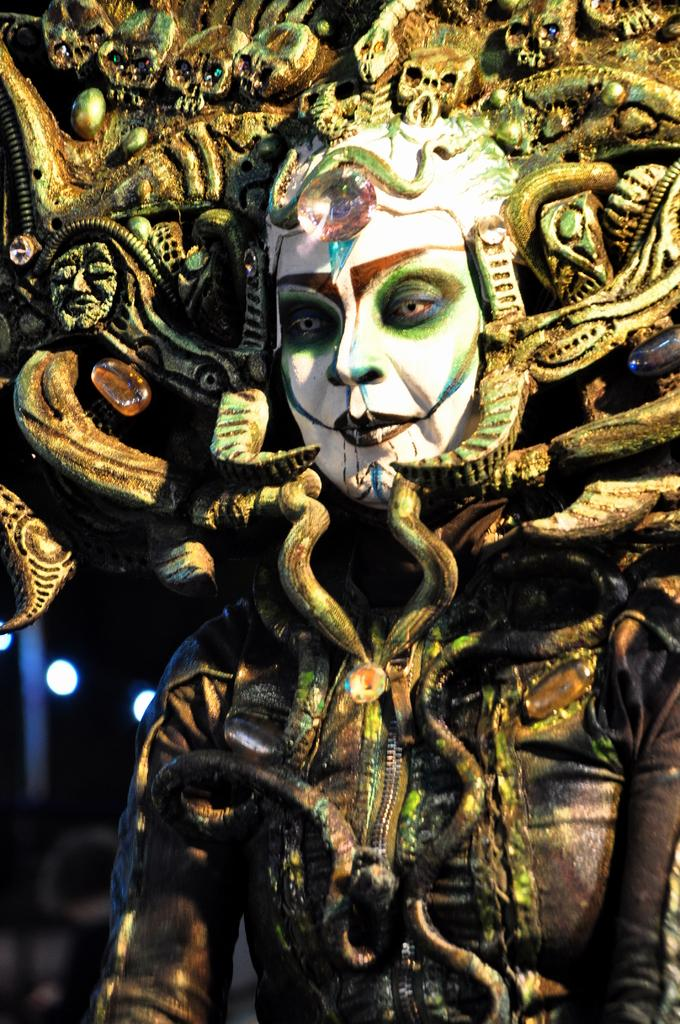What can be seen in the image? There is a person in the image. What is the person wearing? The person is wearing a costume. Can you describe the background of the image? The background of the image is blurry. How many beds are visible in the image? There are no beds visible in the image. What type of shade is covering the person in the image? There is no shade covering the person in the image. 